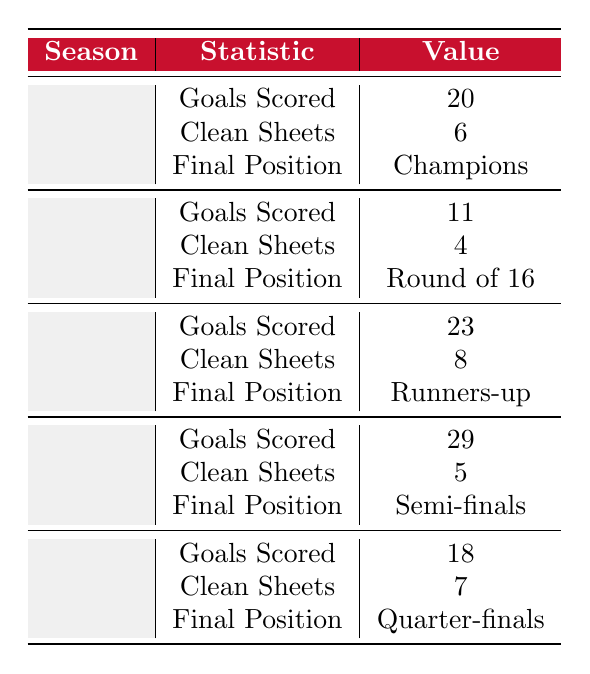What was Liverpool's final position in the 2004-05 Champions League season? The table shows the statistics for each season. For the 2004-05 season, the final position listed is "Champions."
Answer: Champions How many goals did Liverpool score in the 2006-07 Champions League season? The table indicates that Liverpool scored 23 goals in the 2006-07 season.
Answer: 23 Did Liverpool achieve more clean sheets in the 2006-07 season than in the 2005-06 season? In the 2006-07 season, Liverpool had 8 clean sheets, whereas in the 2005-06 season they had 4. Since 8 is greater than 4, the answer is yes.
Answer: Yes What is the total number of goals scored by Liverpool in the Champions League across all seasons listed? To find the total, sum the goals scored: 20 (2004-05) + 11 (2005-06) + 23 (2006-07) + 29 (2007-08) + 18 (2008-09) = 101.
Answer: 101 How many seasons did Liverpool finish in the top position (Champions or Runners-up)? The table shows Liverpool finished as Champions once in 2004-05 and as Runners-up once in 2006-07. Therefore, they finished in the top position in 2 seasons.
Answer: 2 Which season had the lowest number of goals scored by Liverpool? The lowest number of goals scored was in the 2005-06 season, where they scored 11 goals.
Answer: 2005-06 Which season had more clean sheets, 2007-08 or 2008-09? In the 2007-08 season, Liverpool had 5 clean sheets, while in the 2008-09 season they had 7. Since 7 is greater than 5, 2008-09 had more clean sheets.
Answer: 2008-09 What was the average number of goals scored per season by Liverpool in the Champions League during Benitez's tenure? The total number of goals is 101 across 5 seasons. The average is calculated as 101/5 = 20.2.
Answer: 20.2 Based on the table, did Liverpool make it to the semi-finals more than once during Benitez's tenure? The table shows that Liverpool only made it to the semi-finals once in the 2007-08 season. Therefore, the answer is no.
Answer: No What is the difference in clean sheets between the 2006-07 and 2008-09 seasons? In the 2006-07 season, Liverpool had 8 clean sheets, and in the 2008-09 season, they had 7. The difference is 8 - 7 = 1.
Answer: 1 